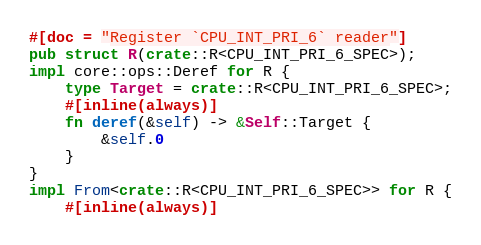<code> <loc_0><loc_0><loc_500><loc_500><_Rust_>#[doc = "Register `CPU_INT_PRI_6` reader"]
pub struct R(crate::R<CPU_INT_PRI_6_SPEC>);
impl core::ops::Deref for R {
    type Target = crate::R<CPU_INT_PRI_6_SPEC>;
    #[inline(always)]
    fn deref(&self) -> &Self::Target {
        &self.0
    }
}
impl From<crate::R<CPU_INT_PRI_6_SPEC>> for R {
    #[inline(always)]</code> 